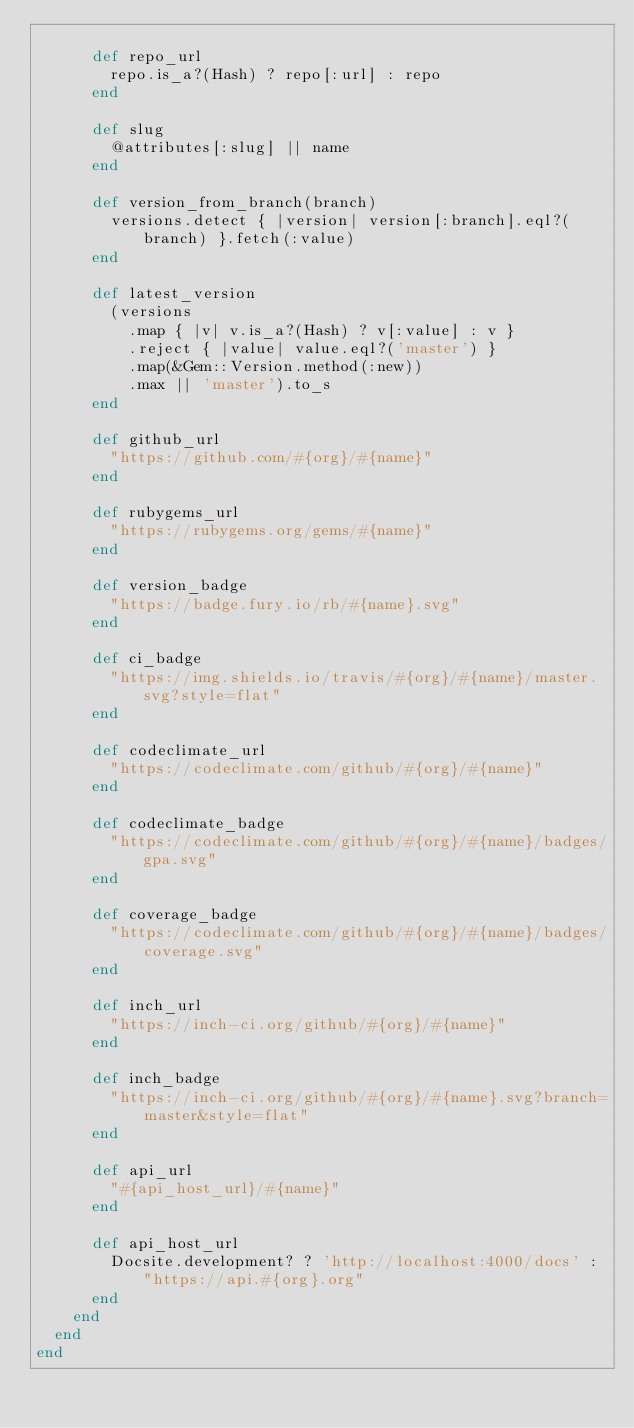<code> <loc_0><loc_0><loc_500><loc_500><_Ruby_>
      def repo_url
        repo.is_a?(Hash) ? repo[:url] : repo
      end

      def slug
        @attributes[:slug] || name
      end

      def version_from_branch(branch)
        versions.detect { |version| version[:branch].eql?(branch) }.fetch(:value)
      end

      def latest_version
        (versions
          .map { |v| v.is_a?(Hash) ? v[:value] : v }
          .reject { |value| value.eql?('master') }
          .map(&Gem::Version.method(:new))
          .max || 'master').to_s
      end

      def github_url
        "https://github.com/#{org}/#{name}"
      end

      def rubygems_url
        "https://rubygems.org/gems/#{name}"
      end

      def version_badge
        "https://badge.fury.io/rb/#{name}.svg"
      end

      def ci_badge
        "https://img.shields.io/travis/#{org}/#{name}/master.svg?style=flat"
      end

      def codeclimate_url
        "https://codeclimate.com/github/#{org}/#{name}"
      end

      def codeclimate_badge
        "https://codeclimate.com/github/#{org}/#{name}/badges/gpa.svg"
      end

      def coverage_badge
        "https://codeclimate.com/github/#{org}/#{name}/badges/coverage.svg"
      end

      def inch_url
        "https://inch-ci.org/github/#{org}/#{name}"
      end

      def inch_badge
        "https://inch-ci.org/github/#{org}/#{name}.svg?branch=master&style=flat"
      end

      def api_url
        "#{api_host_url}/#{name}"
      end

      def api_host_url
        Docsite.development? ? 'http://localhost:4000/docs' : "https://api.#{org}.org"
      end
    end
  end
end
</code> 